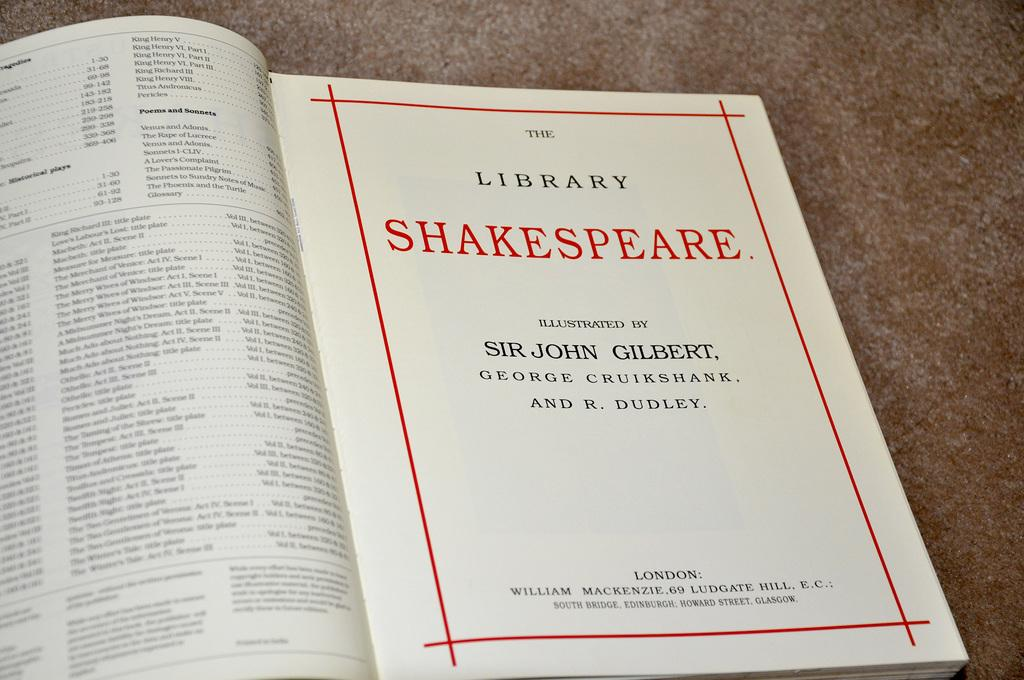<image>
Summarize the visual content of the image. Book with the words Library and Shakespeare wrote on it. 